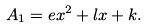<formula> <loc_0><loc_0><loc_500><loc_500>A _ { 1 } = e x ^ { 2 } + l x + k .</formula> 